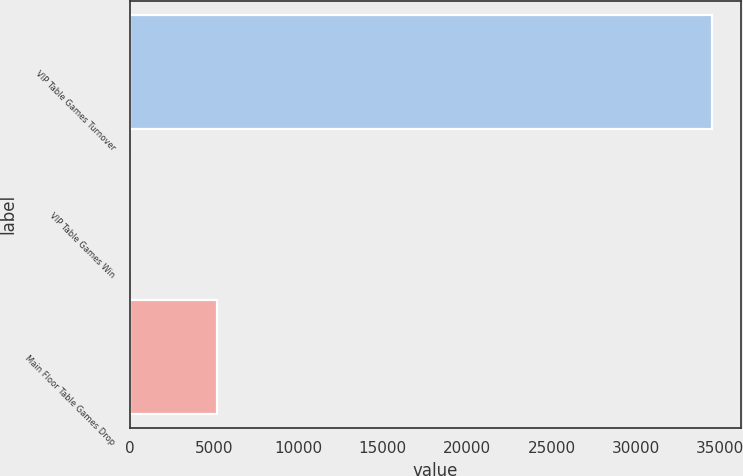<chart> <loc_0><loc_0><loc_500><loc_500><bar_chart><fcel>VIP Table Games Turnover<fcel>VIP Table Games Win<fcel>Main Floor Table Games Drop<nl><fcel>34533<fcel>3.2<fcel>5159<nl></chart> 